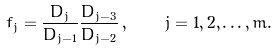Convert formula to latex. <formula><loc_0><loc_0><loc_500><loc_500>f _ { j } = \frac { D _ { j } } { D _ { j - 1 } } \frac { D _ { j - 3 } } { D _ { j - 2 } } \, , \quad j = 1 , 2 , \dots , m .</formula> 